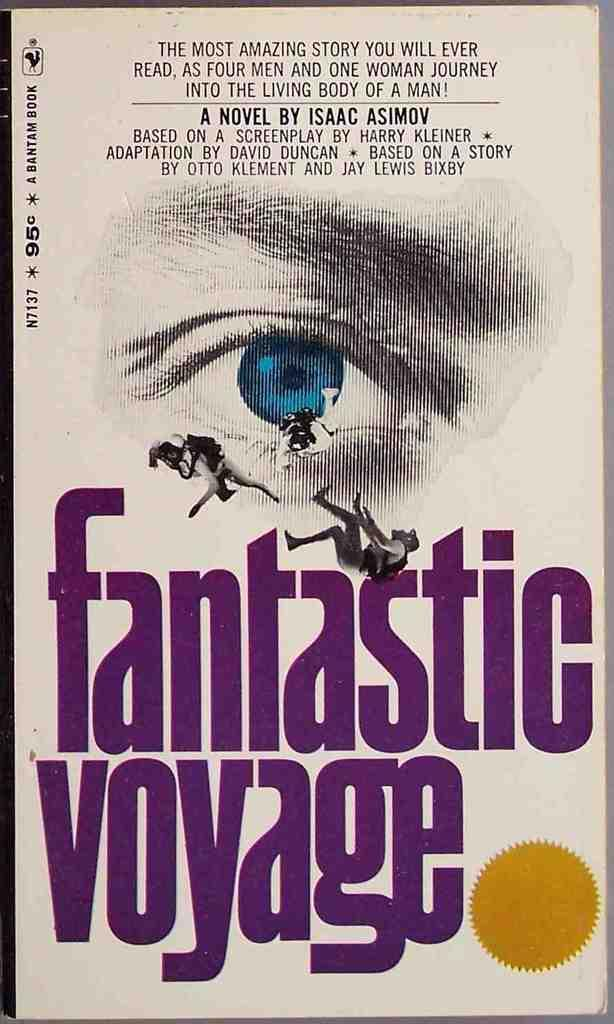<image>
Describe the image concisely. The cover of Fantastic Voyage shows a big blue eye. 